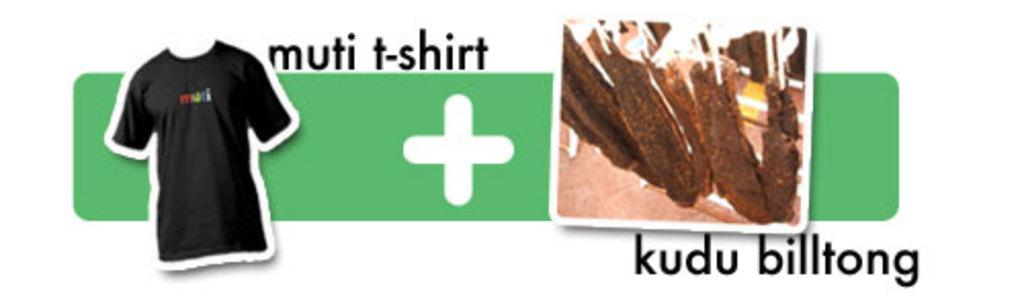<image>
Provide a brief description of the given image. Logo that has the words "kudu billtong" on it. 